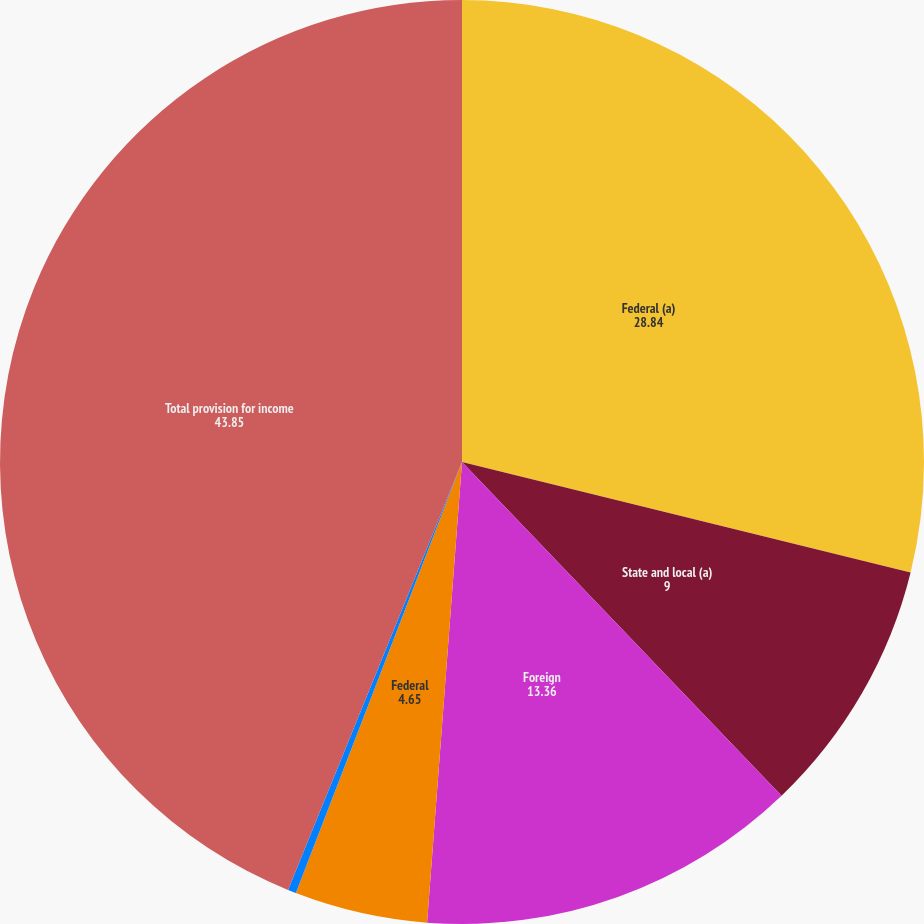Convert chart to OTSL. <chart><loc_0><loc_0><loc_500><loc_500><pie_chart><fcel>Federal (a)<fcel>State and local (a)<fcel>Foreign<fcel>Federal<fcel>State and local<fcel>Total provision for income<nl><fcel>28.84%<fcel>9.0%<fcel>13.36%<fcel>4.65%<fcel>0.29%<fcel>43.85%<nl></chart> 